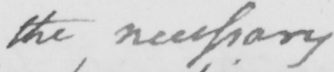Can you read and transcribe this handwriting? the necessary 